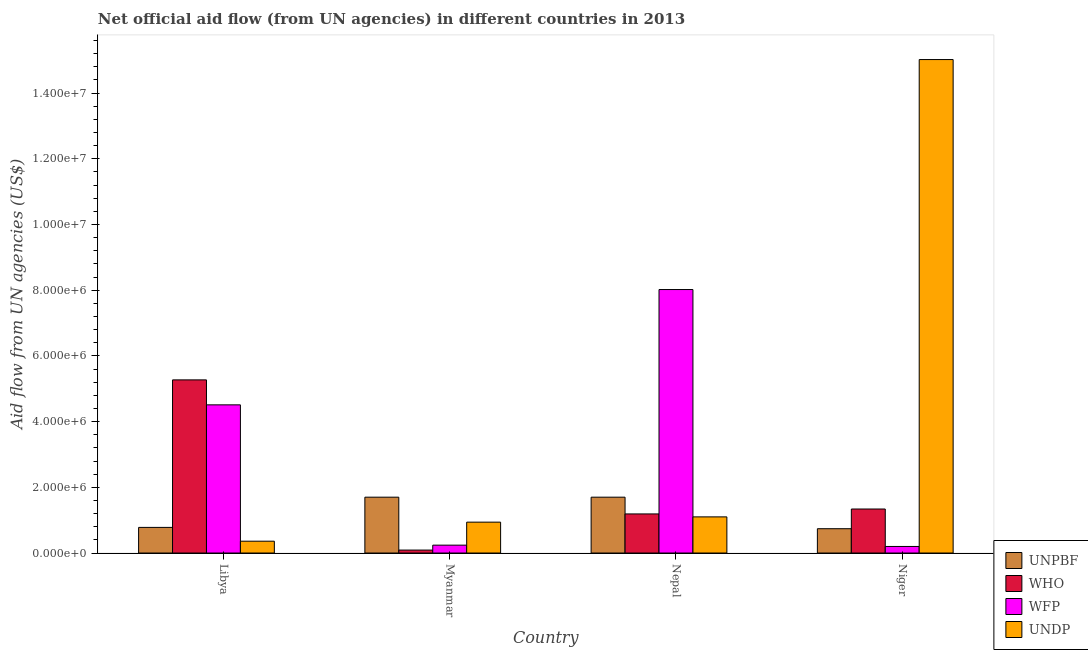How many different coloured bars are there?
Provide a succinct answer. 4. How many bars are there on the 1st tick from the right?
Ensure brevity in your answer.  4. What is the label of the 3rd group of bars from the left?
Offer a terse response. Nepal. What is the amount of aid given by undp in Myanmar?
Provide a succinct answer. 9.40e+05. Across all countries, what is the maximum amount of aid given by undp?
Your answer should be very brief. 1.50e+07. Across all countries, what is the minimum amount of aid given by unpbf?
Make the answer very short. 7.40e+05. In which country was the amount of aid given by undp maximum?
Provide a succinct answer. Niger. In which country was the amount of aid given by who minimum?
Provide a succinct answer. Myanmar. What is the total amount of aid given by unpbf in the graph?
Provide a short and direct response. 4.92e+06. What is the difference between the amount of aid given by wfp in Myanmar and that in Niger?
Provide a short and direct response. 4.00e+04. What is the difference between the amount of aid given by unpbf in Niger and the amount of aid given by who in Nepal?
Your response must be concise. -4.50e+05. What is the average amount of aid given by who per country?
Keep it short and to the point. 1.97e+06. What is the difference between the amount of aid given by unpbf and amount of aid given by wfp in Myanmar?
Provide a succinct answer. 1.46e+06. What is the ratio of the amount of aid given by unpbf in Nepal to that in Niger?
Your answer should be very brief. 2.3. Is the amount of aid given by wfp in Nepal less than that in Niger?
Provide a short and direct response. No. Is the difference between the amount of aid given by who in Myanmar and Niger greater than the difference between the amount of aid given by unpbf in Myanmar and Niger?
Offer a very short reply. No. What is the difference between the highest and the second highest amount of aid given by wfp?
Make the answer very short. 3.51e+06. What is the difference between the highest and the lowest amount of aid given by unpbf?
Offer a very short reply. 9.60e+05. Is the sum of the amount of aid given by undp in Libya and Myanmar greater than the maximum amount of aid given by who across all countries?
Your answer should be compact. No. Is it the case that in every country, the sum of the amount of aid given by wfp and amount of aid given by unpbf is greater than the sum of amount of aid given by undp and amount of aid given by who?
Your answer should be compact. No. What does the 3rd bar from the left in Myanmar represents?
Offer a terse response. WFP. What does the 4th bar from the right in Niger represents?
Keep it short and to the point. UNPBF. What is the difference between two consecutive major ticks on the Y-axis?
Keep it short and to the point. 2.00e+06. Are the values on the major ticks of Y-axis written in scientific E-notation?
Ensure brevity in your answer.  Yes. Does the graph contain any zero values?
Offer a very short reply. No. Does the graph contain grids?
Ensure brevity in your answer.  No. Where does the legend appear in the graph?
Keep it short and to the point. Bottom right. How are the legend labels stacked?
Offer a very short reply. Vertical. What is the title of the graph?
Provide a succinct answer. Net official aid flow (from UN agencies) in different countries in 2013. What is the label or title of the X-axis?
Provide a succinct answer. Country. What is the label or title of the Y-axis?
Provide a succinct answer. Aid flow from UN agencies (US$). What is the Aid flow from UN agencies (US$) in UNPBF in Libya?
Ensure brevity in your answer.  7.80e+05. What is the Aid flow from UN agencies (US$) of WHO in Libya?
Your answer should be compact. 5.27e+06. What is the Aid flow from UN agencies (US$) of WFP in Libya?
Ensure brevity in your answer.  4.51e+06. What is the Aid flow from UN agencies (US$) in UNDP in Libya?
Ensure brevity in your answer.  3.60e+05. What is the Aid flow from UN agencies (US$) of UNPBF in Myanmar?
Make the answer very short. 1.70e+06. What is the Aid flow from UN agencies (US$) of WHO in Myanmar?
Your answer should be very brief. 9.00e+04. What is the Aid flow from UN agencies (US$) of WFP in Myanmar?
Provide a succinct answer. 2.40e+05. What is the Aid flow from UN agencies (US$) of UNDP in Myanmar?
Your answer should be compact. 9.40e+05. What is the Aid flow from UN agencies (US$) in UNPBF in Nepal?
Offer a very short reply. 1.70e+06. What is the Aid flow from UN agencies (US$) of WHO in Nepal?
Make the answer very short. 1.19e+06. What is the Aid flow from UN agencies (US$) of WFP in Nepal?
Your answer should be compact. 8.02e+06. What is the Aid flow from UN agencies (US$) of UNDP in Nepal?
Your answer should be very brief. 1.10e+06. What is the Aid flow from UN agencies (US$) of UNPBF in Niger?
Give a very brief answer. 7.40e+05. What is the Aid flow from UN agencies (US$) in WHO in Niger?
Provide a succinct answer. 1.34e+06. What is the Aid flow from UN agencies (US$) of UNDP in Niger?
Provide a succinct answer. 1.50e+07. Across all countries, what is the maximum Aid flow from UN agencies (US$) in UNPBF?
Give a very brief answer. 1.70e+06. Across all countries, what is the maximum Aid flow from UN agencies (US$) of WHO?
Provide a succinct answer. 5.27e+06. Across all countries, what is the maximum Aid flow from UN agencies (US$) of WFP?
Offer a terse response. 8.02e+06. Across all countries, what is the maximum Aid flow from UN agencies (US$) in UNDP?
Provide a succinct answer. 1.50e+07. Across all countries, what is the minimum Aid flow from UN agencies (US$) of UNPBF?
Ensure brevity in your answer.  7.40e+05. Across all countries, what is the minimum Aid flow from UN agencies (US$) of WHO?
Offer a terse response. 9.00e+04. Across all countries, what is the minimum Aid flow from UN agencies (US$) of UNDP?
Your response must be concise. 3.60e+05. What is the total Aid flow from UN agencies (US$) of UNPBF in the graph?
Give a very brief answer. 4.92e+06. What is the total Aid flow from UN agencies (US$) of WHO in the graph?
Make the answer very short. 7.89e+06. What is the total Aid flow from UN agencies (US$) of WFP in the graph?
Provide a short and direct response. 1.30e+07. What is the total Aid flow from UN agencies (US$) of UNDP in the graph?
Your answer should be compact. 1.74e+07. What is the difference between the Aid flow from UN agencies (US$) of UNPBF in Libya and that in Myanmar?
Offer a terse response. -9.20e+05. What is the difference between the Aid flow from UN agencies (US$) in WHO in Libya and that in Myanmar?
Provide a succinct answer. 5.18e+06. What is the difference between the Aid flow from UN agencies (US$) of WFP in Libya and that in Myanmar?
Offer a very short reply. 4.27e+06. What is the difference between the Aid flow from UN agencies (US$) of UNDP in Libya and that in Myanmar?
Offer a very short reply. -5.80e+05. What is the difference between the Aid flow from UN agencies (US$) in UNPBF in Libya and that in Nepal?
Provide a succinct answer. -9.20e+05. What is the difference between the Aid flow from UN agencies (US$) of WHO in Libya and that in Nepal?
Your answer should be compact. 4.08e+06. What is the difference between the Aid flow from UN agencies (US$) in WFP in Libya and that in Nepal?
Ensure brevity in your answer.  -3.51e+06. What is the difference between the Aid flow from UN agencies (US$) of UNDP in Libya and that in Nepal?
Your answer should be very brief. -7.40e+05. What is the difference between the Aid flow from UN agencies (US$) of UNPBF in Libya and that in Niger?
Provide a short and direct response. 4.00e+04. What is the difference between the Aid flow from UN agencies (US$) in WHO in Libya and that in Niger?
Provide a short and direct response. 3.93e+06. What is the difference between the Aid flow from UN agencies (US$) of WFP in Libya and that in Niger?
Provide a succinct answer. 4.31e+06. What is the difference between the Aid flow from UN agencies (US$) in UNDP in Libya and that in Niger?
Provide a short and direct response. -1.47e+07. What is the difference between the Aid flow from UN agencies (US$) of UNPBF in Myanmar and that in Nepal?
Provide a short and direct response. 0. What is the difference between the Aid flow from UN agencies (US$) in WHO in Myanmar and that in Nepal?
Provide a short and direct response. -1.10e+06. What is the difference between the Aid flow from UN agencies (US$) of WFP in Myanmar and that in Nepal?
Keep it short and to the point. -7.78e+06. What is the difference between the Aid flow from UN agencies (US$) in UNPBF in Myanmar and that in Niger?
Give a very brief answer. 9.60e+05. What is the difference between the Aid flow from UN agencies (US$) in WHO in Myanmar and that in Niger?
Your response must be concise. -1.25e+06. What is the difference between the Aid flow from UN agencies (US$) of WFP in Myanmar and that in Niger?
Provide a succinct answer. 4.00e+04. What is the difference between the Aid flow from UN agencies (US$) in UNDP in Myanmar and that in Niger?
Keep it short and to the point. -1.41e+07. What is the difference between the Aid flow from UN agencies (US$) in UNPBF in Nepal and that in Niger?
Offer a terse response. 9.60e+05. What is the difference between the Aid flow from UN agencies (US$) of WFP in Nepal and that in Niger?
Your response must be concise. 7.82e+06. What is the difference between the Aid flow from UN agencies (US$) in UNDP in Nepal and that in Niger?
Give a very brief answer. -1.39e+07. What is the difference between the Aid flow from UN agencies (US$) of UNPBF in Libya and the Aid flow from UN agencies (US$) of WHO in Myanmar?
Make the answer very short. 6.90e+05. What is the difference between the Aid flow from UN agencies (US$) of UNPBF in Libya and the Aid flow from UN agencies (US$) of WFP in Myanmar?
Provide a succinct answer. 5.40e+05. What is the difference between the Aid flow from UN agencies (US$) of WHO in Libya and the Aid flow from UN agencies (US$) of WFP in Myanmar?
Give a very brief answer. 5.03e+06. What is the difference between the Aid flow from UN agencies (US$) in WHO in Libya and the Aid flow from UN agencies (US$) in UNDP in Myanmar?
Your answer should be compact. 4.33e+06. What is the difference between the Aid flow from UN agencies (US$) in WFP in Libya and the Aid flow from UN agencies (US$) in UNDP in Myanmar?
Ensure brevity in your answer.  3.57e+06. What is the difference between the Aid flow from UN agencies (US$) in UNPBF in Libya and the Aid flow from UN agencies (US$) in WHO in Nepal?
Offer a terse response. -4.10e+05. What is the difference between the Aid flow from UN agencies (US$) of UNPBF in Libya and the Aid flow from UN agencies (US$) of WFP in Nepal?
Your answer should be very brief. -7.24e+06. What is the difference between the Aid flow from UN agencies (US$) of UNPBF in Libya and the Aid flow from UN agencies (US$) of UNDP in Nepal?
Keep it short and to the point. -3.20e+05. What is the difference between the Aid flow from UN agencies (US$) of WHO in Libya and the Aid flow from UN agencies (US$) of WFP in Nepal?
Make the answer very short. -2.75e+06. What is the difference between the Aid flow from UN agencies (US$) in WHO in Libya and the Aid flow from UN agencies (US$) in UNDP in Nepal?
Keep it short and to the point. 4.17e+06. What is the difference between the Aid flow from UN agencies (US$) in WFP in Libya and the Aid flow from UN agencies (US$) in UNDP in Nepal?
Make the answer very short. 3.41e+06. What is the difference between the Aid flow from UN agencies (US$) in UNPBF in Libya and the Aid flow from UN agencies (US$) in WHO in Niger?
Give a very brief answer. -5.60e+05. What is the difference between the Aid flow from UN agencies (US$) in UNPBF in Libya and the Aid flow from UN agencies (US$) in WFP in Niger?
Give a very brief answer. 5.80e+05. What is the difference between the Aid flow from UN agencies (US$) in UNPBF in Libya and the Aid flow from UN agencies (US$) in UNDP in Niger?
Your answer should be compact. -1.42e+07. What is the difference between the Aid flow from UN agencies (US$) of WHO in Libya and the Aid flow from UN agencies (US$) of WFP in Niger?
Offer a terse response. 5.07e+06. What is the difference between the Aid flow from UN agencies (US$) in WHO in Libya and the Aid flow from UN agencies (US$) in UNDP in Niger?
Ensure brevity in your answer.  -9.75e+06. What is the difference between the Aid flow from UN agencies (US$) in WFP in Libya and the Aid flow from UN agencies (US$) in UNDP in Niger?
Offer a terse response. -1.05e+07. What is the difference between the Aid flow from UN agencies (US$) in UNPBF in Myanmar and the Aid flow from UN agencies (US$) in WHO in Nepal?
Your response must be concise. 5.10e+05. What is the difference between the Aid flow from UN agencies (US$) of UNPBF in Myanmar and the Aid flow from UN agencies (US$) of WFP in Nepal?
Your answer should be compact. -6.32e+06. What is the difference between the Aid flow from UN agencies (US$) in UNPBF in Myanmar and the Aid flow from UN agencies (US$) in UNDP in Nepal?
Provide a succinct answer. 6.00e+05. What is the difference between the Aid flow from UN agencies (US$) in WHO in Myanmar and the Aid flow from UN agencies (US$) in WFP in Nepal?
Give a very brief answer. -7.93e+06. What is the difference between the Aid flow from UN agencies (US$) of WHO in Myanmar and the Aid flow from UN agencies (US$) of UNDP in Nepal?
Your answer should be compact. -1.01e+06. What is the difference between the Aid flow from UN agencies (US$) in WFP in Myanmar and the Aid flow from UN agencies (US$) in UNDP in Nepal?
Your response must be concise. -8.60e+05. What is the difference between the Aid flow from UN agencies (US$) of UNPBF in Myanmar and the Aid flow from UN agencies (US$) of WHO in Niger?
Give a very brief answer. 3.60e+05. What is the difference between the Aid flow from UN agencies (US$) in UNPBF in Myanmar and the Aid flow from UN agencies (US$) in WFP in Niger?
Keep it short and to the point. 1.50e+06. What is the difference between the Aid flow from UN agencies (US$) of UNPBF in Myanmar and the Aid flow from UN agencies (US$) of UNDP in Niger?
Give a very brief answer. -1.33e+07. What is the difference between the Aid flow from UN agencies (US$) of WHO in Myanmar and the Aid flow from UN agencies (US$) of WFP in Niger?
Offer a very short reply. -1.10e+05. What is the difference between the Aid flow from UN agencies (US$) in WHO in Myanmar and the Aid flow from UN agencies (US$) in UNDP in Niger?
Offer a terse response. -1.49e+07. What is the difference between the Aid flow from UN agencies (US$) of WFP in Myanmar and the Aid flow from UN agencies (US$) of UNDP in Niger?
Your answer should be compact. -1.48e+07. What is the difference between the Aid flow from UN agencies (US$) in UNPBF in Nepal and the Aid flow from UN agencies (US$) in WFP in Niger?
Your answer should be very brief. 1.50e+06. What is the difference between the Aid flow from UN agencies (US$) of UNPBF in Nepal and the Aid flow from UN agencies (US$) of UNDP in Niger?
Make the answer very short. -1.33e+07. What is the difference between the Aid flow from UN agencies (US$) in WHO in Nepal and the Aid flow from UN agencies (US$) in WFP in Niger?
Your answer should be compact. 9.90e+05. What is the difference between the Aid flow from UN agencies (US$) in WHO in Nepal and the Aid flow from UN agencies (US$) in UNDP in Niger?
Your response must be concise. -1.38e+07. What is the difference between the Aid flow from UN agencies (US$) in WFP in Nepal and the Aid flow from UN agencies (US$) in UNDP in Niger?
Offer a very short reply. -7.00e+06. What is the average Aid flow from UN agencies (US$) of UNPBF per country?
Your response must be concise. 1.23e+06. What is the average Aid flow from UN agencies (US$) in WHO per country?
Keep it short and to the point. 1.97e+06. What is the average Aid flow from UN agencies (US$) of WFP per country?
Make the answer very short. 3.24e+06. What is the average Aid flow from UN agencies (US$) of UNDP per country?
Make the answer very short. 4.36e+06. What is the difference between the Aid flow from UN agencies (US$) in UNPBF and Aid flow from UN agencies (US$) in WHO in Libya?
Give a very brief answer. -4.49e+06. What is the difference between the Aid flow from UN agencies (US$) of UNPBF and Aid flow from UN agencies (US$) of WFP in Libya?
Make the answer very short. -3.73e+06. What is the difference between the Aid flow from UN agencies (US$) of WHO and Aid flow from UN agencies (US$) of WFP in Libya?
Offer a terse response. 7.60e+05. What is the difference between the Aid flow from UN agencies (US$) in WHO and Aid flow from UN agencies (US$) in UNDP in Libya?
Keep it short and to the point. 4.91e+06. What is the difference between the Aid flow from UN agencies (US$) in WFP and Aid flow from UN agencies (US$) in UNDP in Libya?
Ensure brevity in your answer.  4.15e+06. What is the difference between the Aid flow from UN agencies (US$) of UNPBF and Aid flow from UN agencies (US$) of WHO in Myanmar?
Your response must be concise. 1.61e+06. What is the difference between the Aid flow from UN agencies (US$) in UNPBF and Aid flow from UN agencies (US$) in WFP in Myanmar?
Provide a short and direct response. 1.46e+06. What is the difference between the Aid flow from UN agencies (US$) in UNPBF and Aid flow from UN agencies (US$) in UNDP in Myanmar?
Provide a short and direct response. 7.60e+05. What is the difference between the Aid flow from UN agencies (US$) of WHO and Aid flow from UN agencies (US$) of WFP in Myanmar?
Offer a terse response. -1.50e+05. What is the difference between the Aid flow from UN agencies (US$) in WHO and Aid flow from UN agencies (US$) in UNDP in Myanmar?
Your response must be concise. -8.50e+05. What is the difference between the Aid flow from UN agencies (US$) of WFP and Aid flow from UN agencies (US$) of UNDP in Myanmar?
Ensure brevity in your answer.  -7.00e+05. What is the difference between the Aid flow from UN agencies (US$) of UNPBF and Aid flow from UN agencies (US$) of WHO in Nepal?
Make the answer very short. 5.10e+05. What is the difference between the Aid flow from UN agencies (US$) of UNPBF and Aid flow from UN agencies (US$) of WFP in Nepal?
Keep it short and to the point. -6.32e+06. What is the difference between the Aid flow from UN agencies (US$) in WHO and Aid flow from UN agencies (US$) in WFP in Nepal?
Give a very brief answer. -6.83e+06. What is the difference between the Aid flow from UN agencies (US$) of WFP and Aid flow from UN agencies (US$) of UNDP in Nepal?
Offer a terse response. 6.92e+06. What is the difference between the Aid flow from UN agencies (US$) of UNPBF and Aid flow from UN agencies (US$) of WHO in Niger?
Keep it short and to the point. -6.00e+05. What is the difference between the Aid flow from UN agencies (US$) in UNPBF and Aid flow from UN agencies (US$) in WFP in Niger?
Provide a short and direct response. 5.40e+05. What is the difference between the Aid flow from UN agencies (US$) of UNPBF and Aid flow from UN agencies (US$) of UNDP in Niger?
Make the answer very short. -1.43e+07. What is the difference between the Aid flow from UN agencies (US$) in WHO and Aid flow from UN agencies (US$) in WFP in Niger?
Provide a short and direct response. 1.14e+06. What is the difference between the Aid flow from UN agencies (US$) of WHO and Aid flow from UN agencies (US$) of UNDP in Niger?
Provide a short and direct response. -1.37e+07. What is the difference between the Aid flow from UN agencies (US$) in WFP and Aid flow from UN agencies (US$) in UNDP in Niger?
Give a very brief answer. -1.48e+07. What is the ratio of the Aid flow from UN agencies (US$) of UNPBF in Libya to that in Myanmar?
Offer a terse response. 0.46. What is the ratio of the Aid flow from UN agencies (US$) of WHO in Libya to that in Myanmar?
Offer a very short reply. 58.56. What is the ratio of the Aid flow from UN agencies (US$) of WFP in Libya to that in Myanmar?
Ensure brevity in your answer.  18.79. What is the ratio of the Aid flow from UN agencies (US$) of UNDP in Libya to that in Myanmar?
Offer a very short reply. 0.38. What is the ratio of the Aid flow from UN agencies (US$) of UNPBF in Libya to that in Nepal?
Offer a very short reply. 0.46. What is the ratio of the Aid flow from UN agencies (US$) in WHO in Libya to that in Nepal?
Ensure brevity in your answer.  4.43. What is the ratio of the Aid flow from UN agencies (US$) of WFP in Libya to that in Nepal?
Provide a succinct answer. 0.56. What is the ratio of the Aid flow from UN agencies (US$) of UNDP in Libya to that in Nepal?
Your answer should be very brief. 0.33. What is the ratio of the Aid flow from UN agencies (US$) of UNPBF in Libya to that in Niger?
Offer a very short reply. 1.05. What is the ratio of the Aid flow from UN agencies (US$) in WHO in Libya to that in Niger?
Your answer should be very brief. 3.93. What is the ratio of the Aid flow from UN agencies (US$) of WFP in Libya to that in Niger?
Keep it short and to the point. 22.55. What is the ratio of the Aid flow from UN agencies (US$) in UNDP in Libya to that in Niger?
Your response must be concise. 0.02. What is the ratio of the Aid flow from UN agencies (US$) in WHO in Myanmar to that in Nepal?
Give a very brief answer. 0.08. What is the ratio of the Aid flow from UN agencies (US$) of WFP in Myanmar to that in Nepal?
Make the answer very short. 0.03. What is the ratio of the Aid flow from UN agencies (US$) of UNDP in Myanmar to that in Nepal?
Offer a very short reply. 0.85. What is the ratio of the Aid flow from UN agencies (US$) in UNPBF in Myanmar to that in Niger?
Your response must be concise. 2.3. What is the ratio of the Aid flow from UN agencies (US$) in WHO in Myanmar to that in Niger?
Offer a terse response. 0.07. What is the ratio of the Aid flow from UN agencies (US$) in UNDP in Myanmar to that in Niger?
Provide a short and direct response. 0.06. What is the ratio of the Aid flow from UN agencies (US$) of UNPBF in Nepal to that in Niger?
Your answer should be compact. 2.3. What is the ratio of the Aid flow from UN agencies (US$) of WHO in Nepal to that in Niger?
Offer a terse response. 0.89. What is the ratio of the Aid flow from UN agencies (US$) in WFP in Nepal to that in Niger?
Your answer should be compact. 40.1. What is the ratio of the Aid flow from UN agencies (US$) of UNDP in Nepal to that in Niger?
Your response must be concise. 0.07. What is the difference between the highest and the second highest Aid flow from UN agencies (US$) in WHO?
Your answer should be very brief. 3.93e+06. What is the difference between the highest and the second highest Aid flow from UN agencies (US$) of WFP?
Offer a very short reply. 3.51e+06. What is the difference between the highest and the second highest Aid flow from UN agencies (US$) in UNDP?
Keep it short and to the point. 1.39e+07. What is the difference between the highest and the lowest Aid flow from UN agencies (US$) of UNPBF?
Offer a terse response. 9.60e+05. What is the difference between the highest and the lowest Aid flow from UN agencies (US$) in WHO?
Provide a succinct answer. 5.18e+06. What is the difference between the highest and the lowest Aid flow from UN agencies (US$) in WFP?
Offer a very short reply. 7.82e+06. What is the difference between the highest and the lowest Aid flow from UN agencies (US$) of UNDP?
Your response must be concise. 1.47e+07. 